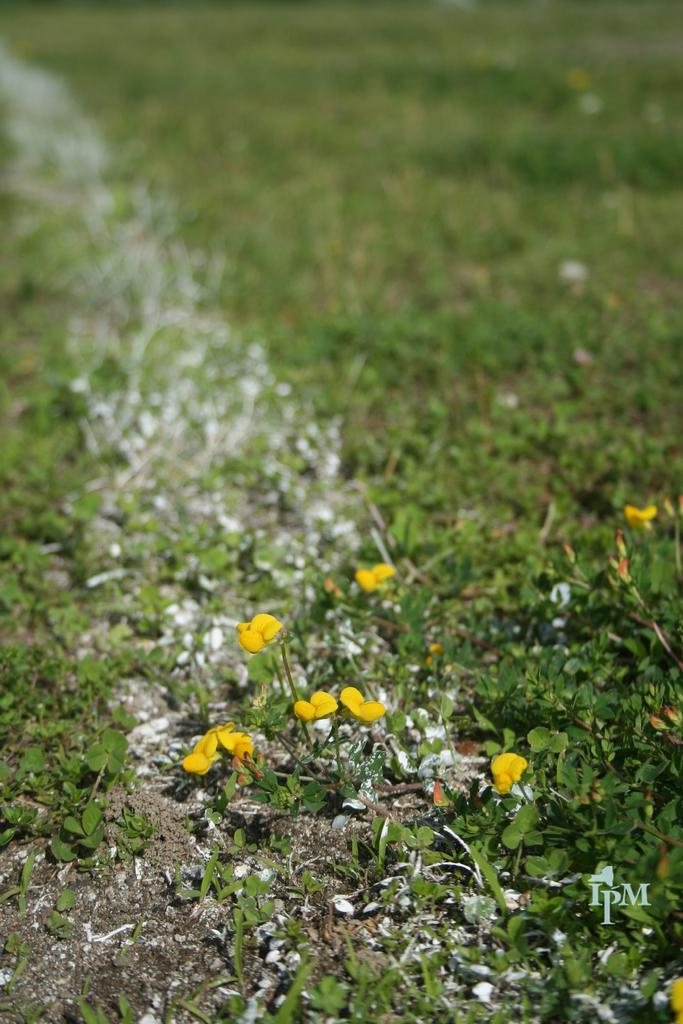What type of flowers can be seen in the image? There are small yellow flowers and small white flowers in the image. What is the background of the flowers in the image? The flowers are surrounded by grass. Where are the flowers and grass located in the image? The flowers and grass are on the ground. What type of wood is used to make the veil in the image? There is no wood or veil present in the image; it features small yellow and white flowers surrounded by grass. 